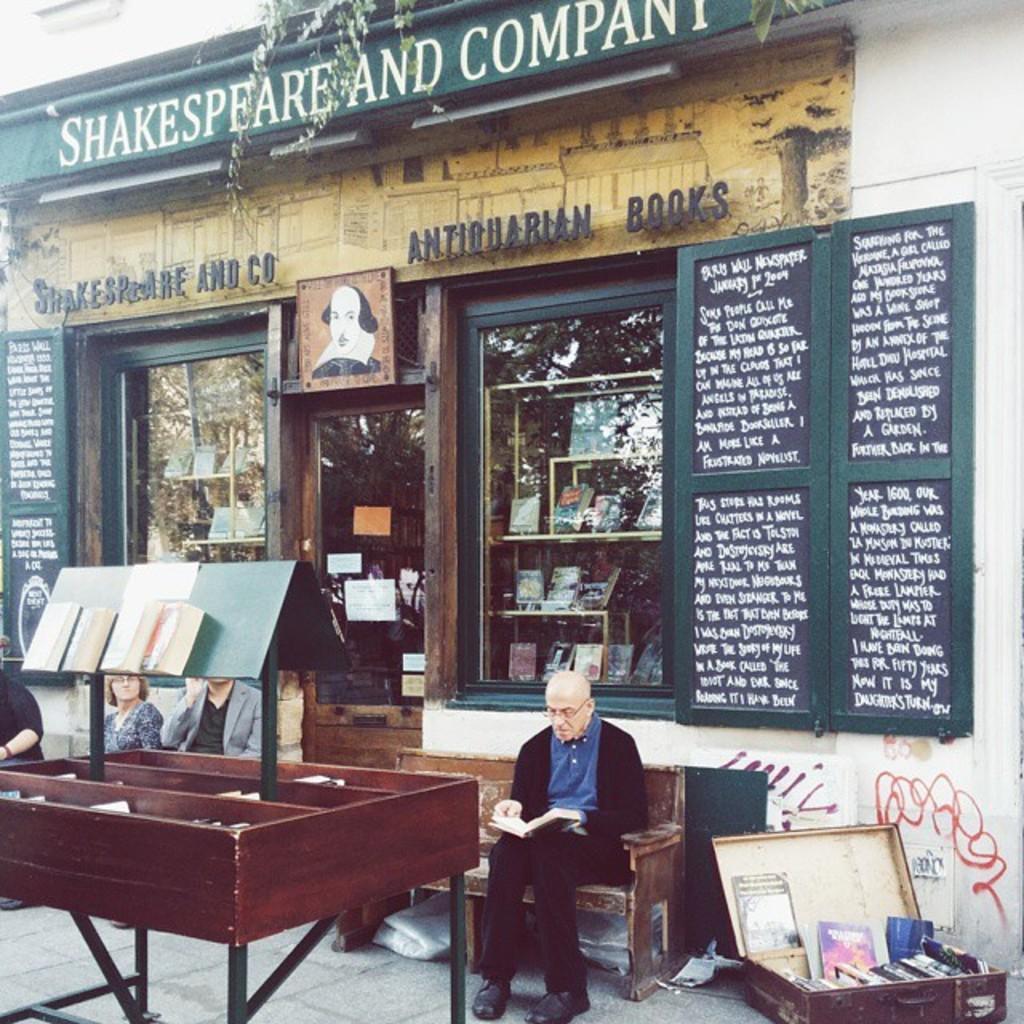Can you describe this image briefly? There is a person sitting on a bench and reading a book. In front of him there is a wooden object. On that there are books. In the back there is a building with windows, door and something written on that. Through the windows we can see books. In the right bottom corner there is a box. There are books in the box. 